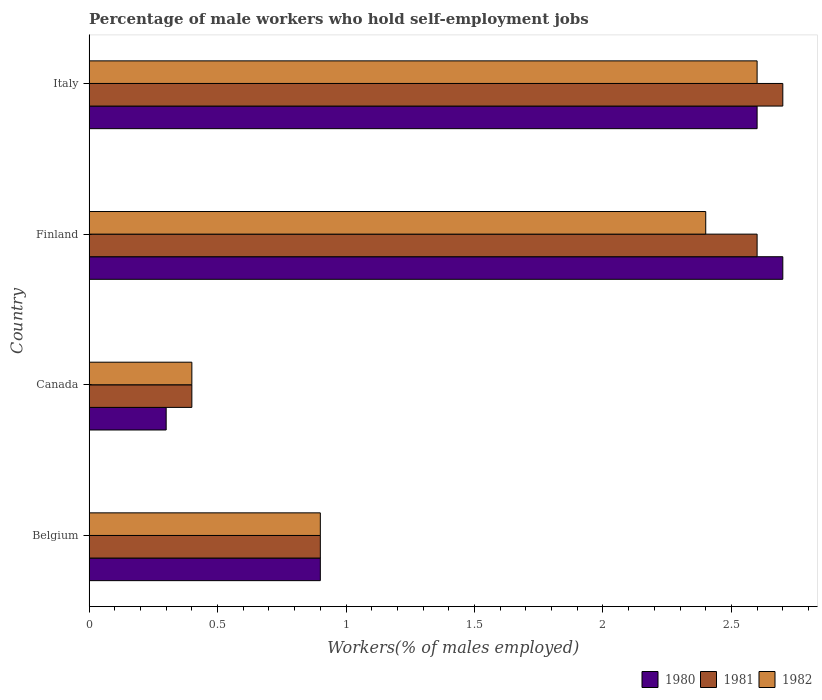How many groups of bars are there?
Give a very brief answer. 4. Are the number of bars on each tick of the Y-axis equal?
Your answer should be very brief. Yes. How many bars are there on the 1st tick from the top?
Give a very brief answer. 3. How many bars are there on the 1st tick from the bottom?
Your response must be concise. 3. What is the percentage of self-employed male workers in 1981 in Italy?
Provide a succinct answer. 2.7. Across all countries, what is the maximum percentage of self-employed male workers in 1982?
Offer a very short reply. 2.6. Across all countries, what is the minimum percentage of self-employed male workers in 1980?
Your response must be concise. 0.3. In which country was the percentage of self-employed male workers in 1980 maximum?
Keep it short and to the point. Finland. In which country was the percentage of self-employed male workers in 1981 minimum?
Your answer should be compact. Canada. What is the total percentage of self-employed male workers in 1980 in the graph?
Provide a succinct answer. 6.5. What is the difference between the percentage of self-employed male workers in 1980 in Finland and that in Italy?
Your answer should be very brief. 0.1. What is the difference between the percentage of self-employed male workers in 1982 in Canada and the percentage of self-employed male workers in 1981 in Belgium?
Offer a very short reply. -0.5. What is the average percentage of self-employed male workers in 1980 per country?
Your answer should be very brief. 1.62. What is the difference between the percentage of self-employed male workers in 1981 and percentage of self-employed male workers in 1980 in Canada?
Make the answer very short. 0.1. In how many countries, is the percentage of self-employed male workers in 1981 greater than 1.8 %?
Your answer should be very brief. 2. What is the ratio of the percentage of self-employed male workers in 1981 in Belgium to that in Finland?
Ensure brevity in your answer.  0.35. Is the difference between the percentage of self-employed male workers in 1981 in Canada and Italy greater than the difference between the percentage of self-employed male workers in 1980 in Canada and Italy?
Provide a succinct answer. No. What is the difference between the highest and the second highest percentage of self-employed male workers in 1980?
Give a very brief answer. 0.1. What is the difference between the highest and the lowest percentage of self-employed male workers in 1982?
Ensure brevity in your answer.  2.2. How many bars are there?
Your answer should be compact. 12. Are all the bars in the graph horizontal?
Give a very brief answer. Yes. How many countries are there in the graph?
Ensure brevity in your answer.  4. What is the difference between two consecutive major ticks on the X-axis?
Ensure brevity in your answer.  0.5. Does the graph contain any zero values?
Your answer should be compact. No. What is the title of the graph?
Give a very brief answer. Percentage of male workers who hold self-employment jobs. Does "2012" appear as one of the legend labels in the graph?
Keep it short and to the point. No. What is the label or title of the X-axis?
Your answer should be very brief. Workers(% of males employed). What is the label or title of the Y-axis?
Make the answer very short. Country. What is the Workers(% of males employed) in 1980 in Belgium?
Give a very brief answer. 0.9. What is the Workers(% of males employed) in 1981 in Belgium?
Your response must be concise. 0.9. What is the Workers(% of males employed) of 1982 in Belgium?
Offer a very short reply. 0.9. What is the Workers(% of males employed) of 1980 in Canada?
Provide a short and direct response. 0.3. What is the Workers(% of males employed) of 1981 in Canada?
Your answer should be compact. 0.4. What is the Workers(% of males employed) of 1982 in Canada?
Make the answer very short. 0.4. What is the Workers(% of males employed) in 1980 in Finland?
Provide a succinct answer. 2.7. What is the Workers(% of males employed) of 1981 in Finland?
Keep it short and to the point. 2.6. What is the Workers(% of males employed) of 1982 in Finland?
Keep it short and to the point. 2.4. What is the Workers(% of males employed) of 1980 in Italy?
Give a very brief answer. 2.6. What is the Workers(% of males employed) of 1981 in Italy?
Your response must be concise. 2.7. What is the Workers(% of males employed) of 1982 in Italy?
Offer a very short reply. 2.6. Across all countries, what is the maximum Workers(% of males employed) in 1980?
Ensure brevity in your answer.  2.7. Across all countries, what is the maximum Workers(% of males employed) in 1981?
Provide a succinct answer. 2.7. Across all countries, what is the maximum Workers(% of males employed) of 1982?
Provide a succinct answer. 2.6. Across all countries, what is the minimum Workers(% of males employed) of 1980?
Ensure brevity in your answer.  0.3. Across all countries, what is the minimum Workers(% of males employed) in 1981?
Keep it short and to the point. 0.4. Across all countries, what is the minimum Workers(% of males employed) of 1982?
Offer a terse response. 0.4. What is the difference between the Workers(% of males employed) of 1981 in Belgium and that in Canada?
Offer a terse response. 0.5. What is the difference between the Workers(% of males employed) in 1982 in Belgium and that in Canada?
Your response must be concise. 0.5. What is the difference between the Workers(% of males employed) of 1981 in Belgium and that in Finland?
Offer a very short reply. -1.7. What is the difference between the Workers(% of males employed) of 1981 in Belgium and that in Italy?
Offer a very short reply. -1.8. What is the difference between the Workers(% of males employed) in 1982 in Belgium and that in Italy?
Your answer should be very brief. -1.7. What is the difference between the Workers(% of males employed) in 1980 in Canada and that in Finland?
Offer a terse response. -2.4. What is the difference between the Workers(% of males employed) in 1981 in Canada and that in Finland?
Your answer should be very brief. -2.2. What is the difference between the Workers(% of males employed) in 1980 in Canada and that in Italy?
Your answer should be compact. -2.3. What is the difference between the Workers(% of males employed) of 1982 in Canada and that in Italy?
Ensure brevity in your answer.  -2.2. What is the difference between the Workers(% of males employed) of 1981 in Finland and that in Italy?
Your answer should be compact. -0.1. What is the difference between the Workers(% of males employed) in 1982 in Finland and that in Italy?
Offer a terse response. -0.2. What is the difference between the Workers(% of males employed) of 1980 in Belgium and the Workers(% of males employed) of 1981 in Canada?
Offer a terse response. 0.5. What is the difference between the Workers(% of males employed) in 1981 in Belgium and the Workers(% of males employed) in 1982 in Canada?
Give a very brief answer. 0.5. What is the difference between the Workers(% of males employed) in 1980 in Belgium and the Workers(% of males employed) in 1981 in Finland?
Make the answer very short. -1.7. What is the difference between the Workers(% of males employed) of 1981 in Belgium and the Workers(% of males employed) of 1982 in Finland?
Give a very brief answer. -1.5. What is the difference between the Workers(% of males employed) of 1980 in Belgium and the Workers(% of males employed) of 1982 in Italy?
Offer a very short reply. -1.7. What is the difference between the Workers(% of males employed) of 1981 in Belgium and the Workers(% of males employed) of 1982 in Italy?
Provide a succinct answer. -1.7. What is the difference between the Workers(% of males employed) of 1981 in Canada and the Workers(% of males employed) of 1982 in Finland?
Make the answer very short. -2. What is the difference between the Workers(% of males employed) in 1980 in Canada and the Workers(% of males employed) in 1981 in Italy?
Ensure brevity in your answer.  -2.4. What is the difference between the Workers(% of males employed) in 1980 in Canada and the Workers(% of males employed) in 1982 in Italy?
Offer a very short reply. -2.3. What is the average Workers(% of males employed) in 1980 per country?
Offer a terse response. 1.62. What is the average Workers(% of males employed) in 1981 per country?
Offer a very short reply. 1.65. What is the average Workers(% of males employed) in 1982 per country?
Give a very brief answer. 1.57. What is the difference between the Workers(% of males employed) of 1980 and Workers(% of males employed) of 1982 in Belgium?
Offer a very short reply. 0. What is the difference between the Workers(% of males employed) of 1981 and Workers(% of males employed) of 1982 in Belgium?
Your response must be concise. 0. What is the difference between the Workers(% of males employed) of 1980 and Workers(% of males employed) of 1981 in Canada?
Provide a short and direct response. -0.1. What is the difference between the Workers(% of males employed) in 1980 and Workers(% of males employed) in 1981 in Finland?
Make the answer very short. 0.1. What is the difference between the Workers(% of males employed) of 1981 and Workers(% of males employed) of 1982 in Finland?
Offer a terse response. 0.2. What is the difference between the Workers(% of males employed) in 1981 and Workers(% of males employed) in 1982 in Italy?
Give a very brief answer. 0.1. What is the ratio of the Workers(% of males employed) of 1980 in Belgium to that in Canada?
Keep it short and to the point. 3. What is the ratio of the Workers(% of males employed) of 1981 in Belgium to that in Canada?
Offer a very short reply. 2.25. What is the ratio of the Workers(% of males employed) of 1982 in Belgium to that in Canada?
Make the answer very short. 2.25. What is the ratio of the Workers(% of males employed) in 1980 in Belgium to that in Finland?
Offer a terse response. 0.33. What is the ratio of the Workers(% of males employed) in 1981 in Belgium to that in Finland?
Offer a very short reply. 0.35. What is the ratio of the Workers(% of males employed) in 1980 in Belgium to that in Italy?
Give a very brief answer. 0.35. What is the ratio of the Workers(% of males employed) of 1981 in Belgium to that in Italy?
Offer a terse response. 0.33. What is the ratio of the Workers(% of males employed) in 1982 in Belgium to that in Italy?
Keep it short and to the point. 0.35. What is the ratio of the Workers(% of males employed) of 1981 in Canada to that in Finland?
Provide a succinct answer. 0.15. What is the ratio of the Workers(% of males employed) of 1980 in Canada to that in Italy?
Offer a very short reply. 0.12. What is the ratio of the Workers(% of males employed) of 1981 in Canada to that in Italy?
Provide a succinct answer. 0.15. What is the ratio of the Workers(% of males employed) in 1982 in Canada to that in Italy?
Your response must be concise. 0.15. What is the difference between the highest and the second highest Workers(% of males employed) of 1980?
Offer a very short reply. 0.1. What is the difference between the highest and the second highest Workers(% of males employed) of 1981?
Give a very brief answer. 0.1. What is the difference between the highest and the lowest Workers(% of males employed) in 1981?
Offer a terse response. 2.3. 